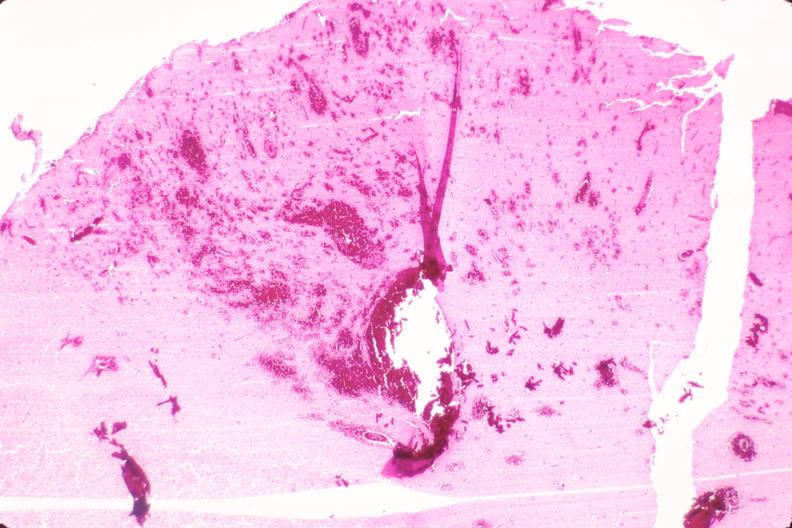s nervous present?
Answer the question using a single word or phrase. Yes 